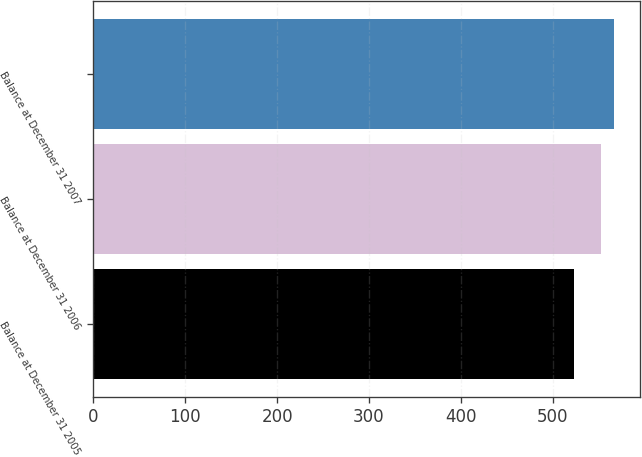Convert chart. <chart><loc_0><loc_0><loc_500><loc_500><bar_chart><fcel>Balance at December 31 2005<fcel>Balance at December 31 2006<fcel>Balance at December 31 2007<nl><fcel>523<fcel>553<fcel>567<nl></chart> 